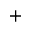Convert formula to latex. <formula><loc_0><loc_0><loc_500><loc_500>^ { + }</formula> 